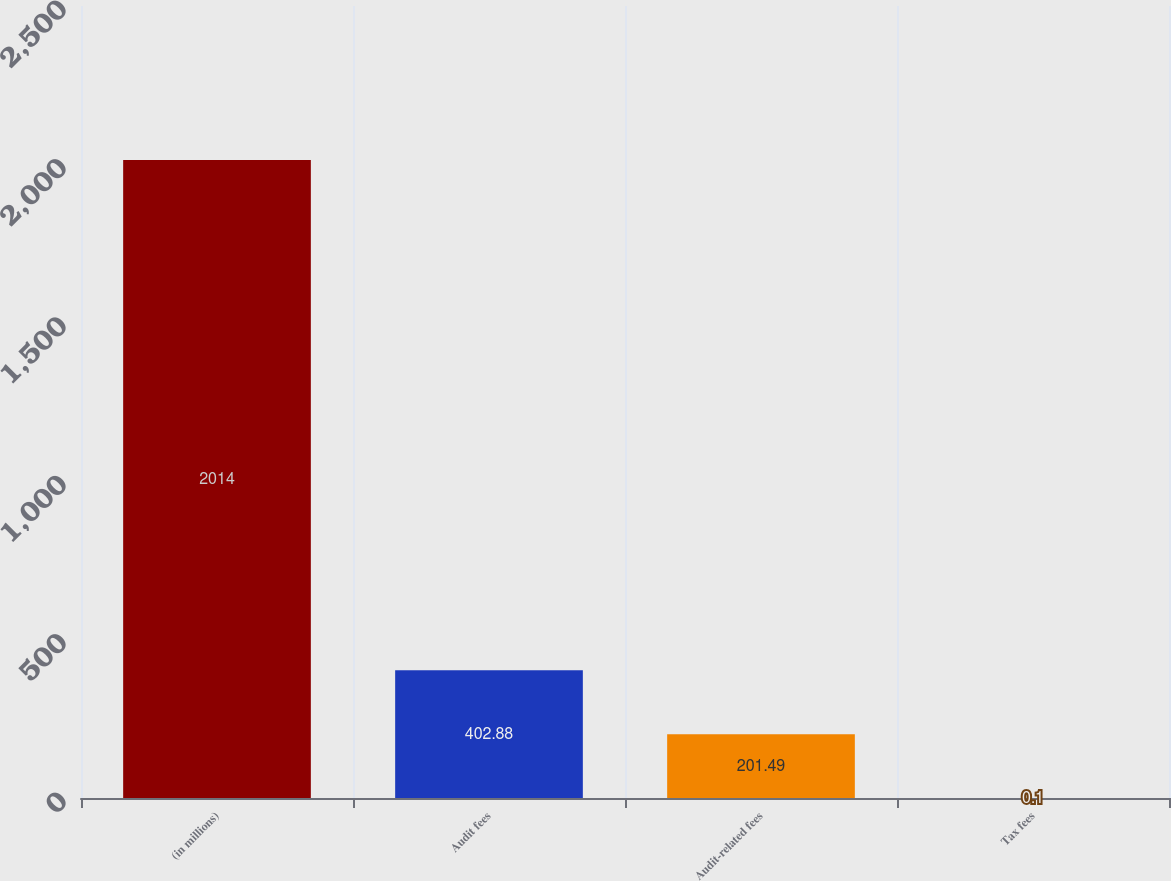<chart> <loc_0><loc_0><loc_500><loc_500><bar_chart><fcel>(in millions)<fcel>Audit fees<fcel>Audit-related fees<fcel>Tax fees<nl><fcel>2014<fcel>402.88<fcel>201.49<fcel>0.1<nl></chart> 